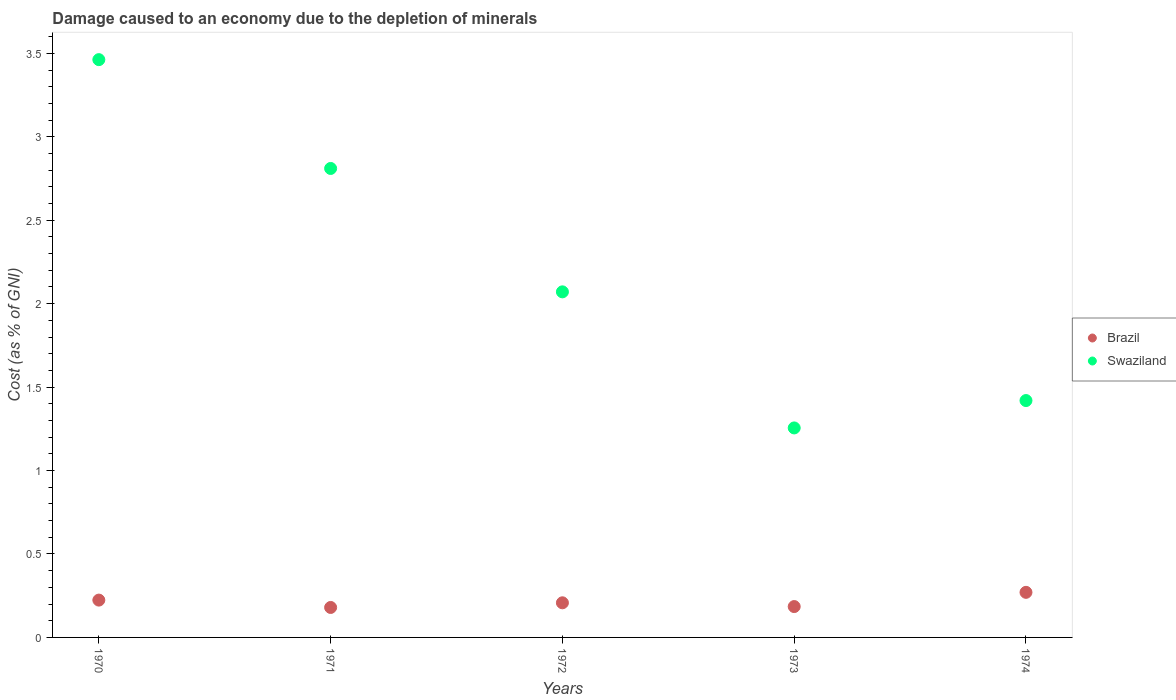How many different coloured dotlines are there?
Offer a very short reply. 2. What is the cost of damage caused due to the depletion of minerals in Brazil in 1974?
Your answer should be very brief. 0.27. Across all years, what is the maximum cost of damage caused due to the depletion of minerals in Brazil?
Make the answer very short. 0.27. Across all years, what is the minimum cost of damage caused due to the depletion of minerals in Brazil?
Offer a very short reply. 0.18. In which year was the cost of damage caused due to the depletion of minerals in Brazil maximum?
Make the answer very short. 1974. In which year was the cost of damage caused due to the depletion of minerals in Swaziland minimum?
Your answer should be compact. 1973. What is the total cost of damage caused due to the depletion of minerals in Swaziland in the graph?
Provide a succinct answer. 11.02. What is the difference between the cost of damage caused due to the depletion of minerals in Brazil in 1972 and that in 1973?
Offer a very short reply. 0.02. What is the difference between the cost of damage caused due to the depletion of minerals in Swaziland in 1972 and the cost of damage caused due to the depletion of minerals in Brazil in 1970?
Keep it short and to the point. 1.85. What is the average cost of damage caused due to the depletion of minerals in Brazil per year?
Your response must be concise. 0.21. In the year 1970, what is the difference between the cost of damage caused due to the depletion of minerals in Brazil and cost of damage caused due to the depletion of minerals in Swaziland?
Your answer should be very brief. -3.24. What is the ratio of the cost of damage caused due to the depletion of minerals in Swaziland in 1970 to that in 1973?
Provide a short and direct response. 2.76. Is the cost of damage caused due to the depletion of minerals in Brazil in 1971 less than that in 1973?
Your answer should be compact. Yes. What is the difference between the highest and the second highest cost of damage caused due to the depletion of minerals in Brazil?
Your response must be concise. 0.05. What is the difference between the highest and the lowest cost of damage caused due to the depletion of minerals in Swaziland?
Your response must be concise. 2.21. Does the cost of damage caused due to the depletion of minerals in Brazil monotonically increase over the years?
Keep it short and to the point. No. How many dotlines are there?
Provide a succinct answer. 2. How many years are there in the graph?
Provide a succinct answer. 5. Does the graph contain any zero values?
Provide a succinct answer. No. Where does the legend appear in the graph?
Keep it short and to the point. Center right. What is the title of the graph?
Your answer should be very brief. Damage caused to an economy due to the depletion of minerals. Does "Belarus" appear as one of the legend labels in the graph?
Give a very brief answer. No. What is the label or title of the Y-axis?
Your answer should be compact. Cost (as % of GNI). What is the Cost (as % of GNI) in Brazil in 1970?
Provide a short and direct response. 0.22. What is the Cost (as % of GNI) of Swaziland in 1970?
Make the answer very short. 3.46. What is the Cost (as % of GNI) of Brazil in 1971?
Make the answer very short. 0.18. What is the Cost (as % of GNI) of Swaziland in 1971?
Ensure brevity in your answer.  2.81. What is the Cost (as % of GNI) in Brazil in 1972?
Ensure brevity in your answer.  0.21. What is the Cost (as % of GNI) in Swaziland in 1972?
Give a very brief answer. 2.07. What is the Cost (as % of GNI) of Brazil in 1973?
Make the answer very short. 0.18. What is the Cost (as % of GNI) in Swaziland in 1973?
Provide a succinct answer. 1.26. What is the Cost (as % of GNI) in Brazil in 1974?
Your response must be concise. 0.27. What is the Cost (as % of GNI) in Swaziland in 1974?
Provide a succinct answer. 1.42. Across all years, what is the maximum Cost (as % of GNI) of Brazil?
Make the answer very short. 0.27. Across all years, what is the maximum Cost (as % of GNI) of Swaziland?
Keep it short and to the point. 3.46. Across all years, what is the minimum Cost (as % of GNI) of Brazil?
Provide a short and direct response. 0.18. Across all years, what is the minimum Cost (as % of GNI) of Swaziland?
Give a very brief answer. 1.26. What is the total Cost (as % of GNI) in Brazil in the graph?
Offer a terse response. 1.07. What is the total Cost (as % of GNI) in Swaziland in the graph?
Make the answer very short. 11.02. What is the difference between the Cost (as % of GNI) of Brazil in 1970 and that in 1971?
Your answer should be compact. 0.04. What is the difference between the Cost (as % of GNI) in Swaziland in 1970 and that in 1971?
Keep it short and to the point. 0.65. What is the difference between the Cost (as % of GNI) of Brazil in 1970 and that in 1972?
Your answer should be compact. 0.02. What is the difference between the Cost (as % of GNI) in Swaziland in 1970 and that in 1972?
Keep it short and to the point. 1.39. What is the difference between the Cost (as % of GNI) in Brazil in 1970 and that in 1973?
Offer a very short reply. 0.04. What is the difference between the Cost (as % of GNI) in Swaziland in 1970 and that in 1973?
Give a very brief answer. 2.21. What is the difference between the Cost (as % of GNI) of Brazil in 1970 and that in 1974?
Your answer should be very brief. -0.05. What is the difference between the Cost (as % of GNI) in Swaziland in 1970 and that in 1974?
Offer a terse response. 2.04. What is the difference between the Cost (as % of GNI) of Brazil in 1971 and that in 1972?
Make the answer very short. -0.03. What is the difference between the Cost (as % of GNI) of Swaziland in 1971 and that in 1972?
Ensure brevity in your answer.  0.74. What is the difference between the Cost (as % of GNI) of Brazil in 1971 and that in 1973?
Provide a short and direct response. -0.01. What is the difference between the Cost (as % of GNI) in Swaziland in 1971 and that in 1973?
Your response must be concise. 1.55. What is the difference between the Cost (as % of GNI) in Brazil in 1971 and that in 1974?
Provide a succinct answer. -0.09. What is the difference between the Cost (as % of GNI) of Swaziland in 1971 and that in 1974?
Your answer should be compact. 1.39. What is the difference between the Cost (as % of GNI) in Brazil in 1972 and that in 1973?
Give a very brief answer. 0.02. What is the difference between the Cost (as % of GNI) of Swaziland in 1972 and that in 1973?
Offer a very short reply. 0.82. What is the difference between the Cost (as % of GNI) of Brazil in 1972 and that in 1974?
Provide a short and direct response. -0.06. What is the difference between the Cost (as % of GNI) of Swaziland in 1972 and that in 1974?
Your answer should be compact. 0.65. What is the difference between the Cost (as % of GNI) in Brazil in 1973 and that in 1974?
Provide a succinct answer. -0.09. What is the difference between the Cost (as % of GNI) in Swaziland in 1973 and that in 1974?
Provide a succinct answer. -0.16. What is the difference between the Cost (as % of GNI) in Brazil in 1970 and the Cost (as % of GNI) in Swaziland in 1971?
Ensure brevity in your answer.  -2.59. What is the difference between the Cost (as % of GNI) in Brazil in 1970 and the Cost (as % of GNI) in Swaziland in 1972?
Keep it short and to the point. -1.85. What is the difference between the Cost (as % of GNI) in Brazil in 1970 and the Cost (as % of GNI) in Swaziland in 1973?
Provide a short and direct response. -1.03. What is the difference between the Cost (as % of GNI) of Brazil in 1970 and the Cost (as % of GNI) of Swaziland in 1974?
Offer a very short reply. -1.2. What is the difference between the Cost (as % of GNI) of Brazil in 1971 and the Cost (as % of GNI) of Swaziland in 1972?
Offer a terse response. -1.89. What is the difference between the Cost (as % of GNI) of Brazil in 1971 and the Cost (as % of GNI) of Swaziland in 1973?
Ensure brevity in your answer.  -1.08. What is the difference between the Cost (as % of GNI) of Brazil in 1971 and the Cost (as % of GNI) of Swaziland in 1974?
Give a very brief answer. -1.24. What is the difference between the Cost (as % of GNI) of Brazil in 1972 and the Cost (as % of GNI) of Swaziland in 1973?
Provide a short and direct response. -1.05. What is the difference between the Cost (as % of GNI) of Brazil in 1972 and the Cost (as % of GNI) of Swaziland in 1974?
Offer a terse response. -1.21. What is the difference between the Cost (as % of GNI) in Brazil in 1973 and the Cost (as % of GNI) in Swaziland in 1974?
Offer a terse response. -1.23. What is the average Cost (as % of GNI) in Brazil per year?
Make the answer very short. 0.21. What is the average Cost (as % of GNI) in Swaziland per year?
Make the answer very short. 2.2. In the year 1970, what is the difference between the Cost (as % of GNI) in Brazil and Cost (as % of GNI) in Swaziland?
Ensure brevity in your answer.  -3.24. In the year 1971, what is the difference between the Cost (as % of GNI) of Brazil and Cost (as % of GNI) of Swaziland?
Provide a short and direct response. -2.63. In the year 1972, what is the difference between the Cost (as % of GNI) in Brazil and Cost (as % of GNI) in Swaziland?
Offer a very short reply. -1.86. In the year 1973, what is the difference between the Cost (as % of GNI) in Brazil and Cost (as % of GNI) in Swaziland?
Give a very brief answer. -1.07. In the year 1974, what is the difference between the Cost (as % of GNI) in Brazil and Cost (as % of GNI) in Swaziland?
Give a very brief answer. -1.15. What is the ratio of the Cost (as % of GNI) in Brazil in 1970 to that in 1971?
Offer a very short reply. 1.25. What is the ratio of the Cost (as % of GNI) in Swaziland in 1970 to that in 1971?
Offer a terse response. 1.23. What is the ratio of the Cost (as % of GNI) in Brazil in 1970 to that in 1972?
Your answer should be very brief. 1.08. What is the ratio of the Cost (as % of GNI) of Swaziland in 1970 to that in 1972?
Keep it short and to the point. 1.67. What is the ratio of the Cost (as % of GNI) of Brazil in 1970 to that in 1973?
Give a very brief answer. 1.21. What is the ratio of the Cost (as % of GNI) of Swaziland in 1970 to that in 1973?
Ensure brevity in your answer.  2.76. What is the ratio of the Cost (as % of GNI) in Brazil in 1970 to that in 1974?
Provide a short and direct response. 0.83. What is the ratio of the Cost (as % of GNI) of Swaziland in 1970 to that in 1974?
Your response must be concise. 2.44. What is the ratio of the Cost (as % of GNI) of Brazil in 1971 to that in 1972?
Offer a very short reply. 0.87. What is the ratio of the Cost (as % of GNI) of Swaziland in 1971 to that in 1972?
Your answer should be very brief. 1.36. What is the ratio of the Cost (as % of GNI) in Brazil in 1971 to that in 1973?
Make the answer very short. 0.97. What is the ratio of the Cost (as % of GNI) in Swaziland in 1971 to that in 1973?
Your answer should be compact. 2.24. What is the ratio of the Cost (as % of GNI) of Brazil in 1971 to that in 1974?
Your response must be concise. 0.66. What is the ratio of the Cost (as % of GNI) in Swaziland in 1971 to that in 1974?
Keep it short and to the point. 1.98. What is the ratio of the Cost (as % of GNI) of Brazil in 1972 to that in 1973?
Your answer should be compact. 1.12. What is the ratio of the Cost (as % of GNI) in Swaziland in 1972 to that in 1973?
Provide a short and direct response. 1.65. What is the ratio of the Cost (as % of GNI) of Brazil in 1972 to that in 1974?
Make the answer very short. 0.77. What is the ratio of the Cost (as % of GNI) of Swaziland in 1972 to that in 1974?
Offer a very short reply. 1.46. What is the ratio of the Cost (as % of GNI) in Brazil in 1973 to that in 1974?
Keep it short and to the point. 0.68. What is the ratio of the Cost (as % of GNI) in Swaziland in 1973 to that in 1974?
Give a very brief answer. 0.88. What is the difference between the highest and the second highest Cost (as % of GNI) of Brazil?
Your answer should be compact. 0.05. What is the difference between the highest and the second highest Cost (as % of GNI) of Swaziland?
Provide a succinct answer. 0.65. What is the difference between the highest and the lowest Cost (as % of GNI) of Brazil?
Provide a short and direct response. 0.09. What is the difference between the highest and the lowest Cost (as % of GNI) of Swaziland?
Give a very brief answer. 2.21. 